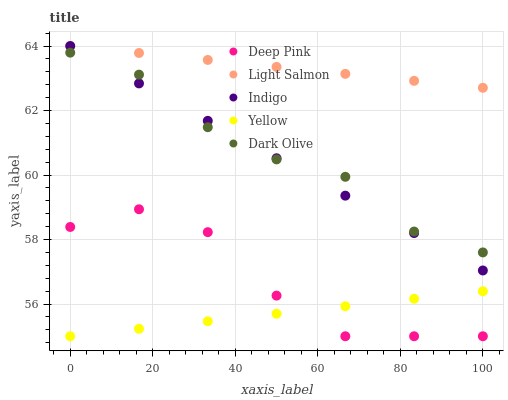Does Yellow have the minimum area under the curve?
Answer yes or no. Yes. Does Light Salmon have the maximum area under the curve?
Answer yes or no. Yes. Does Deep Pink have the minimum area under the curve?
Answer yes or no. No. Does Deep Pink have the maximum area under the curve?
Answer yes or no. No. Is Indigo the smoothest?
Answer yes or no. Yes. Is Deep Pink the roughest?
Answer yes or no. Yes. Is Light Salmon the smoothest?
Answer yes or no. No. Is Light Salmon the roughest?
Answer yes or no. No. Does Deep Pink have the lowest value?
Answer yes or no. Yes. Does Light Salmon have the lowest value?
Answer yes or no. No. Does Indigo have the highest value?
Answer yes or no. Yes. Does Deep Pink have the highest value?
Answer yes or no. No. Is Deep Pink less than Indigo?
Answer yes or no. Yes. Is Light Salmon greater than Yellow?
Answer yes or no. Yes. Does Dark Olive intersect Indigo?
Answer yes or no. Yes. Is Dark Olive less than Indigo?
Answer yes or no. No. Is Dark Olive greater than Indigo?
Answer yes or no. No. Does Deep Pink intersect Indigo?
Answer yes or no. No. 